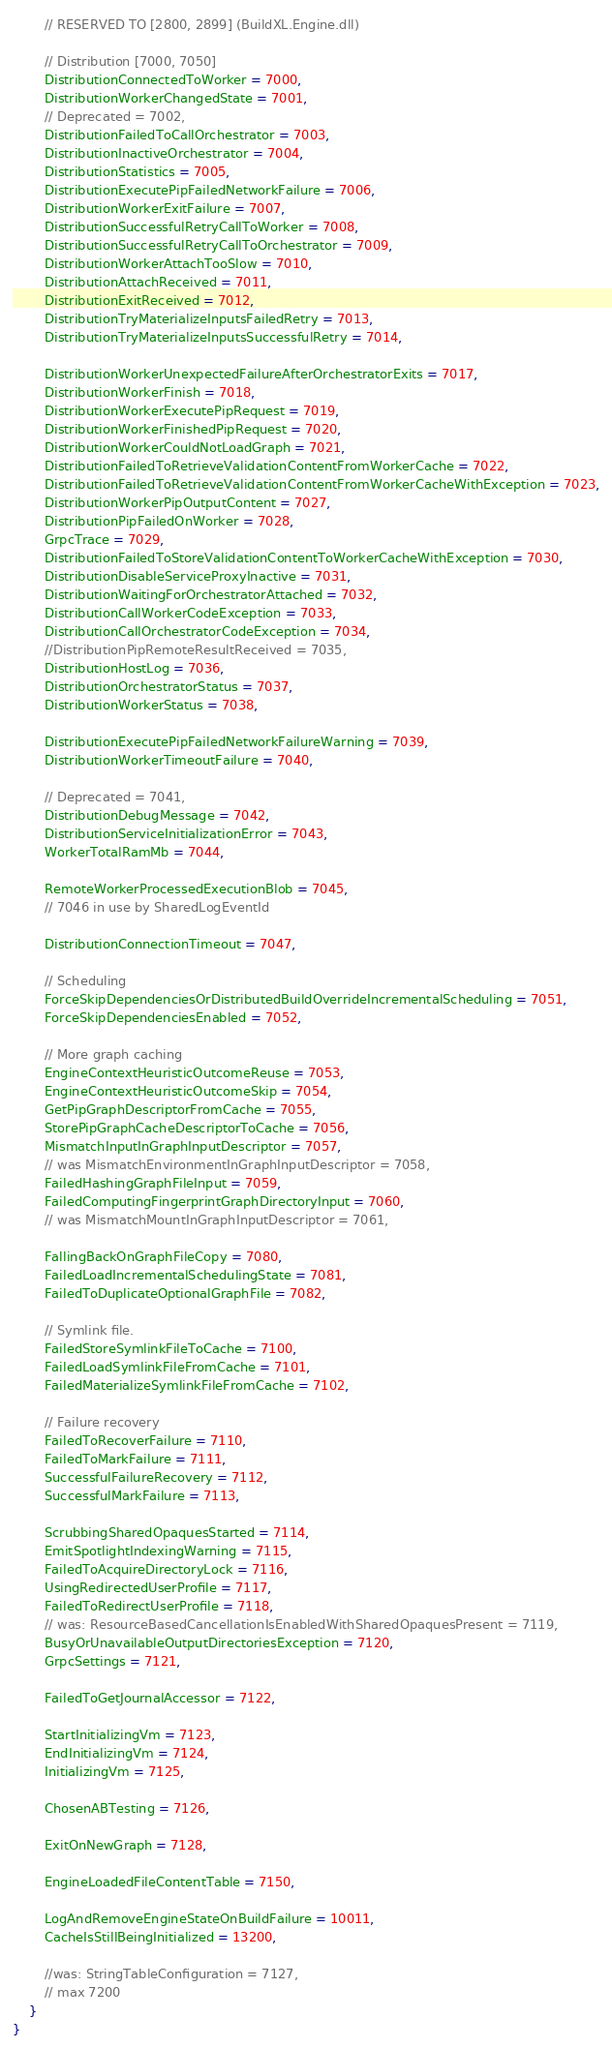Convert code to text. <code><loc_0><loc_0><loc_500><loc_500><_C#_>
        // RESERVED TO [2800, 2899] (BuildXL.Engine.dll)

        // Distribution [7000, 7050]
        DistributionConnectedToWorker = 7000,
        DistributionWorkerChangedState = 7001,
        // Deprecated = 7002,
        DistributionFailedToCallOrchestrator = 7003,
        DistributionInactiveOrchestrator = 7004,
        DistributionStatistics = 7005,
        DistributionExecutePipFailedNetworkFailure = 7006,
        DistributionWorkerExitFailure = 7007,
        DistributionSuccessfulRetryCallToWorker = 7008,
        DistributionSuccessfulRetryCallToOrchestrator = 7009,
        DistributionWorkerAttachTooSlow = 7010,
        DistributionAttachReceived = 7011,
        DistributionExitReceived = 7012,
        DistributionTryMaterializeInputsFailedRetry = 7013,
        DistributionTryMaterializeInputsSuccessfulRetry = 7014,

        DistributionWorkerUnexpectedFailureAfterOrchestratorExits = 7017,
        DistributionWorkerFinish = 7018,
        DistributionWorkerExecutePipRequest = 7019,
        DistributionWorkerFinishedPipRequest = 7020,
        DistributionWorkerCouldNotLoadGraph = 7021,
        DistributionFailedToRetrieveValidationContentFromWorkerCache = 7022,
        DistributionFailedToRetrieveValidationContentFromWorkerCacheWithException = 7023,
        DistributionWorkerPipOutputContent = 7027,
        DistributionPipFailedOnWorker = 7028,
        GrpcTrace = 7029,
        DistributionFailedToStoreValidationContentToWorkerCacheWithException = 7030,
        DistributionDisableServiceProxyInactive = 7031,
        DistributionWaitingForOrchestratorAttached = 7032,
        DistributionCallWorkerCodeException = 7033,
        DistributionCallOrchestratorCodeException = 7034,
        //DistributionPipRemoteResultReceived = 7035,
        DistributionHostLog = 7036,
        DistributionOrchestratorStatus = 7037,
        DistributionWorkerStatus = 7038,

        DistributionExecutePipFailedNetworkFailureWarning = 7039,
        DistributionWorkerTimeoutFailure = 7040,

        // Deprecated = 7041,
        DistributionDebugMessage = 7042,
        DistributionServiceInitializationError = 7043,
        WorkerTotalRamMb = 7044,

        RemoteWorkerProcessedExecutionBlob = 7045,
        // 7046 in use by SharedLogEventId

        DistributionConnectionTimeout = 7047,

        // Scheduling
        ForceSkipDependenciesOrDistributedBuildOverrideIncrementalScheduling = 7051,
        ForceSkipDependenciesEnabled = 7052,

        // More graph caching
        EngineContextHeuristicOutcomeReuse = 7053,
        EngineContextHeuristicOutcomeSkip = 7054,
        GetPipGraphDescriptorFromCache = 7055,
        StorePipGraphCacheDescriptorToCache = 7056,
        MismatchInputInGraphInputDescriptor = 7057,
        // was MismatchEnvironmentInGraphInputDescriptor = 7058,
        FailedHashingGraphFileInput = 7059,
        FailedComputingFingerprintGraphDirectoryInput = 7060,
        // was MismatchMountInGraphInputDescriptor = 7061,

        FallingBackOnGraphFileCopy = 7080,
        FailedLoadIncrementalSchedulingState = 7081,
        FailedToDuplicateOptionalGraphFile = 7082,

        // Symlink file.
        FailedStoreSymlinkFileToCache = 7100,
        FailedLoadSymlinkFileFromCache = 7101,
        FailedMaterializeSymlinkFileFromCache = 7102,

        // Failure recovery
        FailedToRecoverFailure = 7110,
        FailedToMarkFailure = 7111,
        SuccessfulFailureRecovery = 7112,
        SuccessfulMarkFailure = 7113,

        ScrubbingSharedOpaquesStarted = 7114,
        EmitSpotlightIndexingWarning = 7115,
        FailedToAcquireDirectoryLock = 7116,
        UsingRedirectedUserProfile = 7117,
        FailedToRedirectUserProfile = 7118,
        // was: ResourceBasedCancellationIsEnabledWithSharedOpaquesPresent = 7119,
        BusyOrUnavailableOutputDirectoriesException = 7120,
        GrpcSettings = 7121,

        FailedToGetJournalAccessor = 7122,

        StartInitializingVm = 7123,
        EndInitializingVm = 7124,
        InitializingVm = 7125,

        ChosenABTesting = 7126,

        ExitOnNewGraph = 7128,

        EngineLoadedFileContentTable = 7150,

        LogAndRemoveEngineStateOnBuildFailure = 10011,
        CacheIsStillBeingInitialized = 13200,

        //was: StringTableConfiguration = 7127,
        // max 7200
    }
}
</code> 